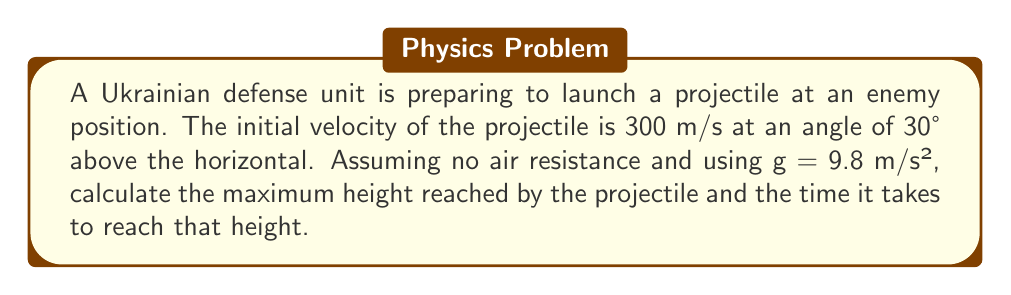Teach me how to tackle this problem. To solve this problem, we'll use the equations of motion for projectile motion. Let's break it down step-by-step:

1) First, we need to find the vertical component of the initial velocity:
   $v_{0y} = v_0 \sin \theta = 300 \sin 30° = 150$ m/s

2) The maximum height is reached when the vertical velocity becomes zero. We can use the equation:
   $v_y^2 = v_{0y}^2 - 2gy$
   At the highest point, $v_y = 0$, so:
   $0 = v_{0y}^2 - 2gy_{max}$
   $2gy_{max} = v_{0y}^2$
   $y_{max} = \frac{v_{0y}^2}{2g} = \frac{150^2}{2(9.8)} = 1148.98$ m

3) To find the time to reach the maximum height, we can use the equation:
   $y = v_{0y}t - \frac{1}{2}gt^2$
   At the highest point, $y = y_{max}$ and $t = t_{max}$:
   $1148.98 = 150t_{max} - \frac{1}{2}(9.8)t_{max}^2$

4) We can also use the simpler equation:
   $v_y = v_{0y} - gt$
   At the highest point, $v_y = 0$:
   $0 = 150 - 9.8t_{max}$
   $t_{max} = \frac{150}{9.8} = 15.31$ s

Therefore, the projectile reaches a maximum height of 1148.98 meters after 15.31 seconds.
Answer: Maximum height: 1148.98 m
Time to reach maximum height: 15.31 s 